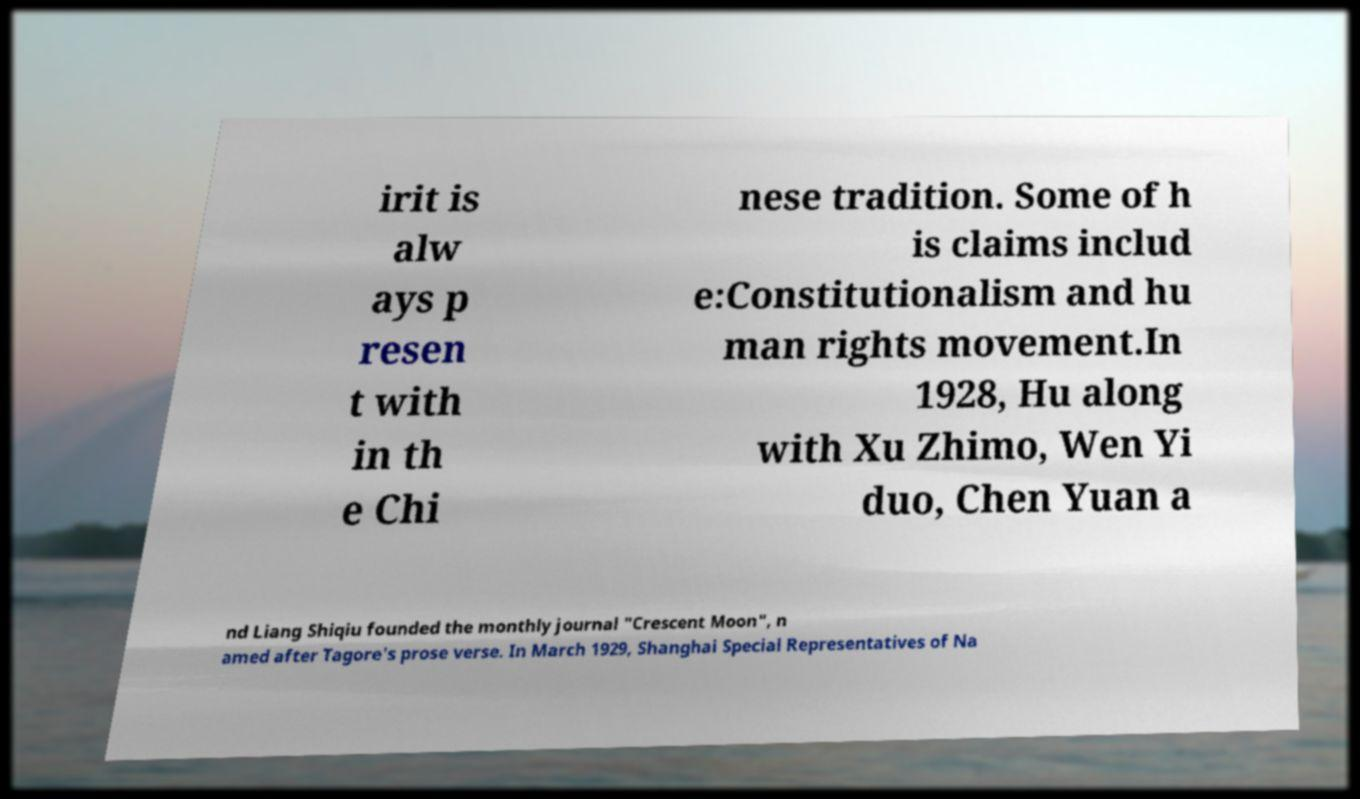Can you read and provide the text displayed in the image?This photo seems to have some interesting text. Can you extract and type it out for me? irit is alw ays p resen t with in th e Chi nese tradition. Some of h is claims includ e:Constitutionalism and hu man rights movement.In 1928, Hu along with Xu Zhimo, Wen Yi duo, Chen Yuan a nd Liang Shiqiu founded the monthly journal "Crescent Moon", n amed after Tagore's prose verse. In March 1929, Shanghai Special Representatives of Na 